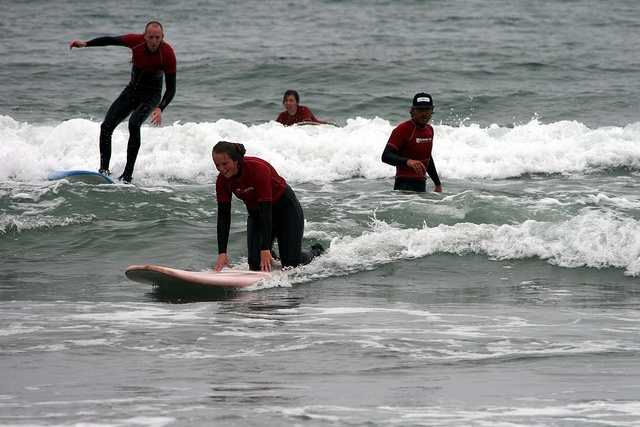Describe the objects in this image and their specific colors. I can see people in gray, black, maroon, and brown tones, people in gray, black, maroon, and darkgray tones, people in gray, black, maroon, and darkgray tones, surfboard in gray, black, lightgray, pink, and darkgray tones, and people in gray, black, maroon, and brown tones in this image. 